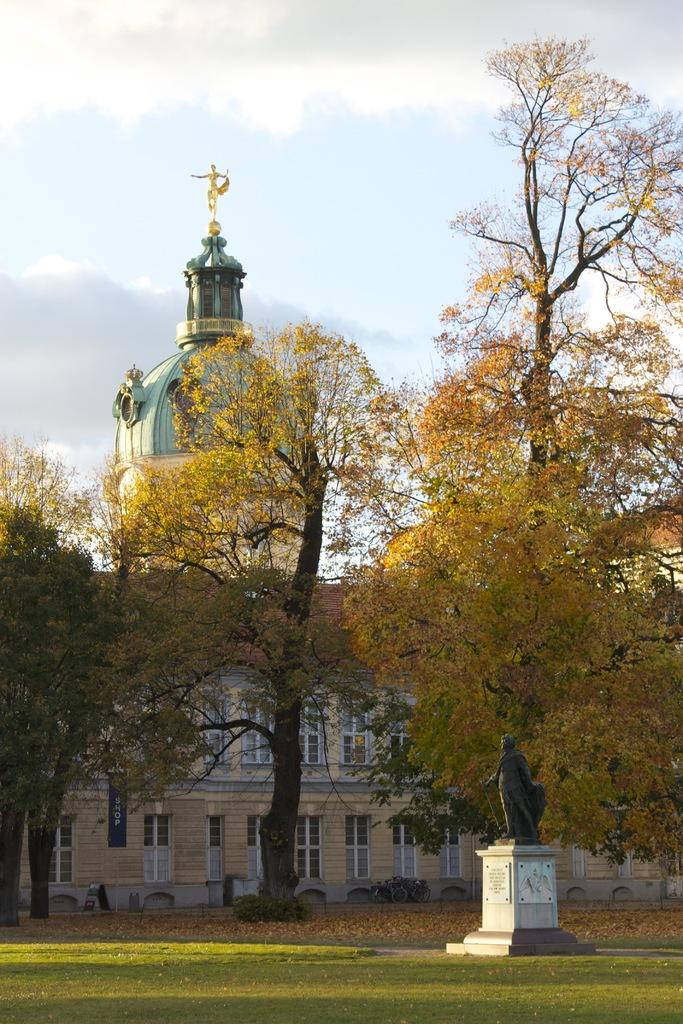What is the main subject in the image? There is a statue in the image. What type of natural environment is visible in the image? There is grass, dry leaves on the ground, and trees in the image. What can be seen in the background of the image? There is a building and the sky visible in the image, such as a building in the background. What is the condition of the sky in the image? The sky is visible in the background of the image, and it has clouds present. How does the statue make the waves in the image quieter? There are no waves present in the image, and the statue does not have any effect on the sound of waves. 